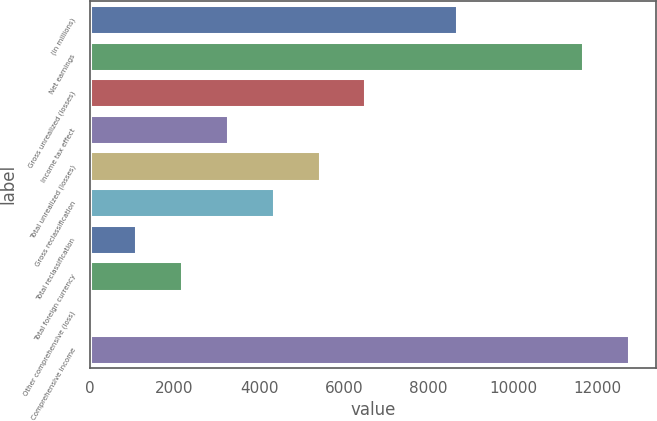Convert chart. <chart><loc_0><loc_0><loc_500><loc_500><bar_chart><fcel>(in millions)<fcel>Net earnings<fcel>Gross unrealized (losses)<fcel>Income tax effect<fcel>Total unrealized (losses)<fcel>Gross reclassification<fcel>Total reclassification<fcel>Total foreign currency<fcel>Other comprehensive (loss)<fcel>Comprehensive income<nl><fcel>8672.4<fcel>11654.3<fcel>6507.8<fcel>3260.9<fcel>5425.5<fcel>4343.2<fcel>1096.3<fcel>2178.6<fcel>14<fcel>12736.6<nl></chart> 